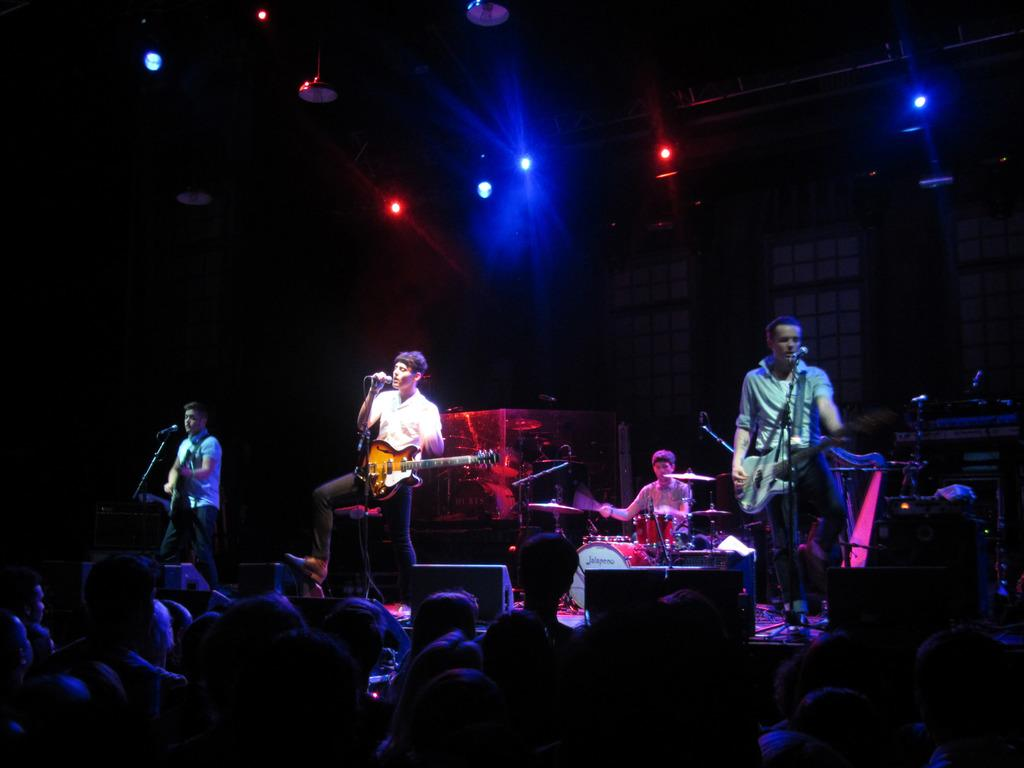What is happening on the stage in the image? There are people on the stage who are performing. What type of performance is taking place? The performance involves playing musical instruments and singing. Who is watching the performance? There is an audience in front of the stage. What can be seen behind the performers on stage? There are lights behind the performers on stage. What type of animal is being transported in a crate on stage? There is no animal or crate present on stage in the image. What unit of measurement is being used to determine the size of the stage? The image does not provide any information about the size of the stage or any units of measurement. 